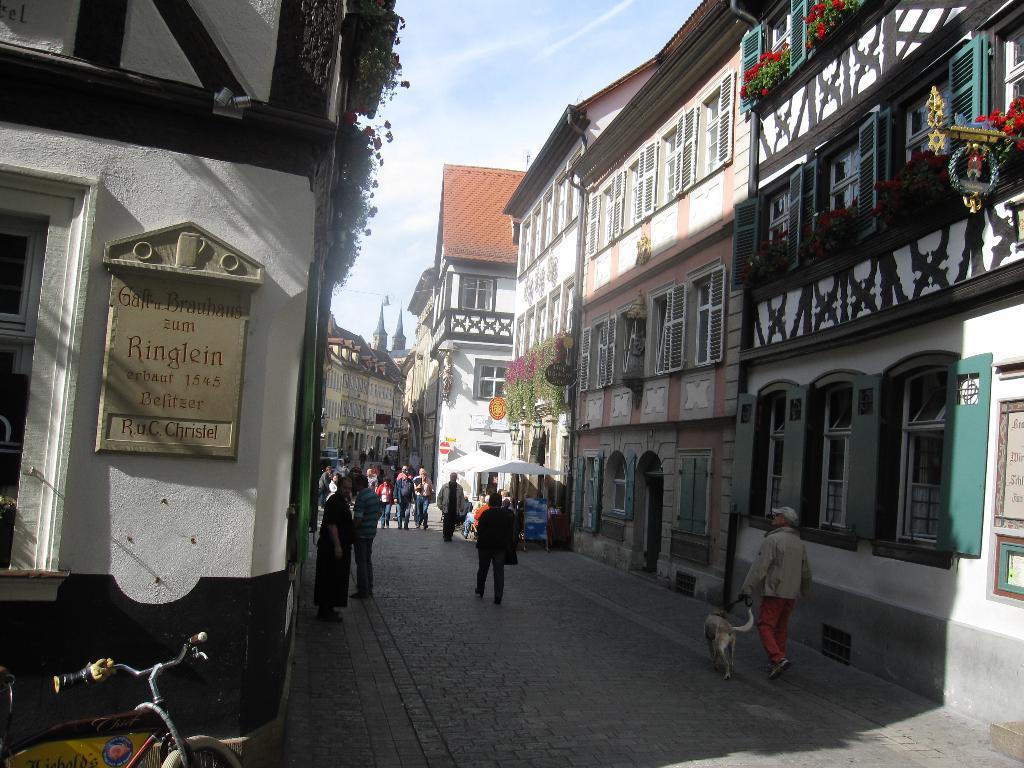Describe this image in one or two sentences. In this image I can see group of people, some are standing and some are walking. In front I can see the dog in cream and white color and I can also see few buildings in white and cream color, few flowers in red color, plants in green color and the sky is in white and blue color. In front I can see the bicycle. 